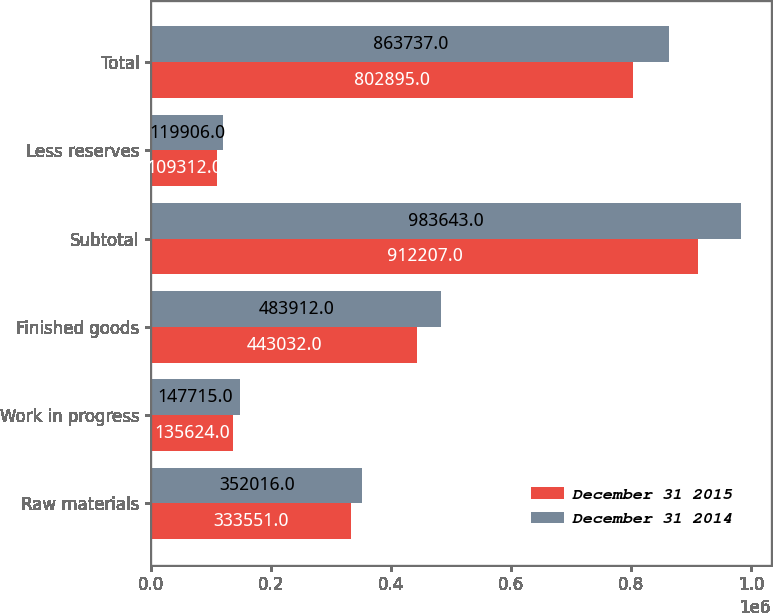<chart> <loc_0><loc_0><loc_500><loc_500><stacked_bar_chart><ecel><fcel>Raw materials<fcel>Work in progress<fcel>Finished goods<fcel>Subtotal<fcel>Less reserves<fcel>Total<nl><fcel>December 31 2015<fcel>333551<fcel>135624<fcel>443032<fcel>912207<fcel>109312<fcel>802895<nl><fcel>December 31 2014<fcel>352016<fcel>147715<fcel>483912<fcel>983643<fcel>119906<fcel>863737<nl></chart> 